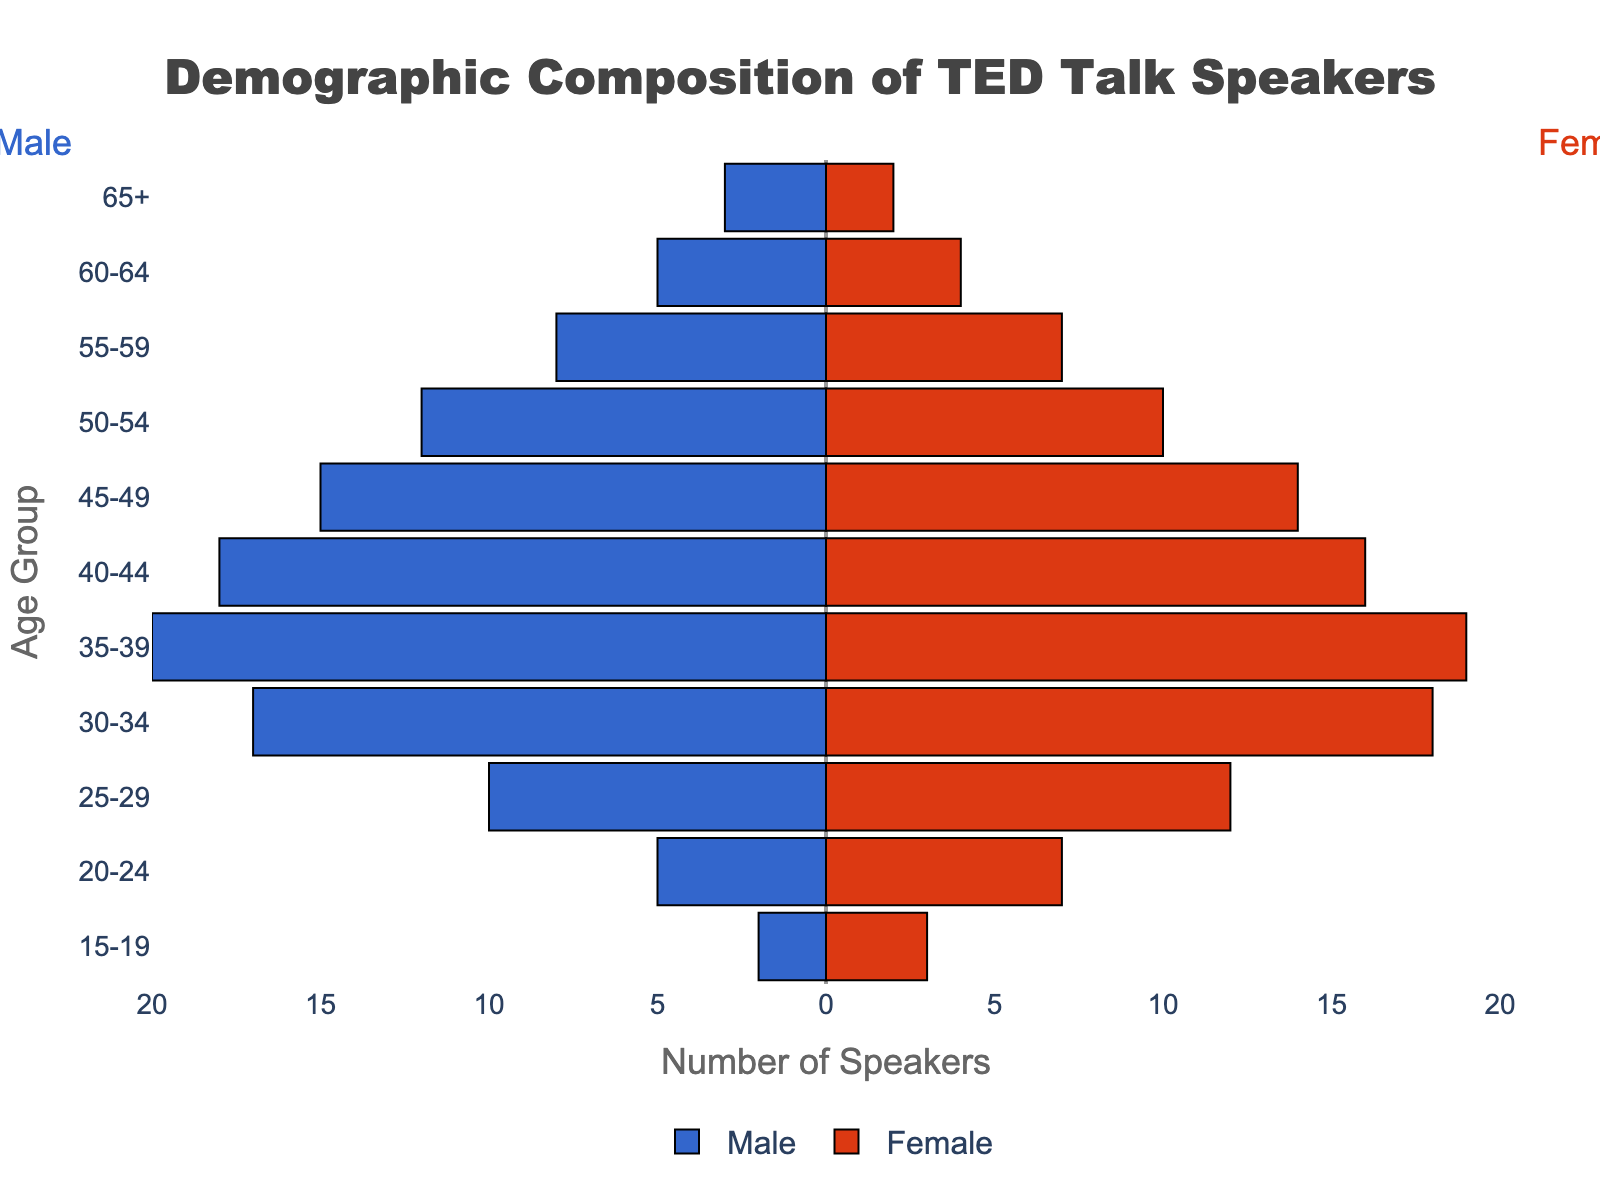What is the title of the figure? The title is located at the top of the figure, generally in a larger font than the other text elements.
Answer: Demographic Composition of TED Talk Speakers What is the age group with the highest number of female speakers? Look for the age group bar on the right side (female) that extends the furthest to the right.
Answer: 35-39 How many male speakers are in the 45-49 age group? Locate the 45-49 age group and read the value of the corresponding male bar, which extends to the left.
Answer: 15 Which gender has more speakers in the 30-34 age group, and by how much? Compare the length of the male and female bars for the 30-34 age group; subtract the smaller value from the larger one.
Answer: Female by 1 How many total speakers are there in the 60-64 age group? Add the number of male and female speakers for the 60-64 age group.
Answer: 9 For which age group is the difference between the number of male and female speakers the largest? Calculate the absolute difference between male and female speakers for each age group and identify the maximum difference.
Answer: 25-29 What is the total number of male speakers across all age groups? Sum the negative values (because males were negated) of all male bars across all age groups.
Answer: 115 Between which two consecutive age groups is the decrease in female speakers the greatest? Compare the female speaker counts for each consecutive age group and identify the pair with the greatest decrease.
Answer: 25-29 and 30-34 What is the range of the x-axis, and how is it labeled? Look at the x-axis from the leftmost to the rightmost tick and note the range and tick labels.
Answer: -20 to 20, labeled in increments of 5 What is the combined total of speakers (male and female) in the 15-19 and 20-24 age groups? Add up the male and female speaker values for both age groups: (2+3) + (5+7)
Answer: 17 